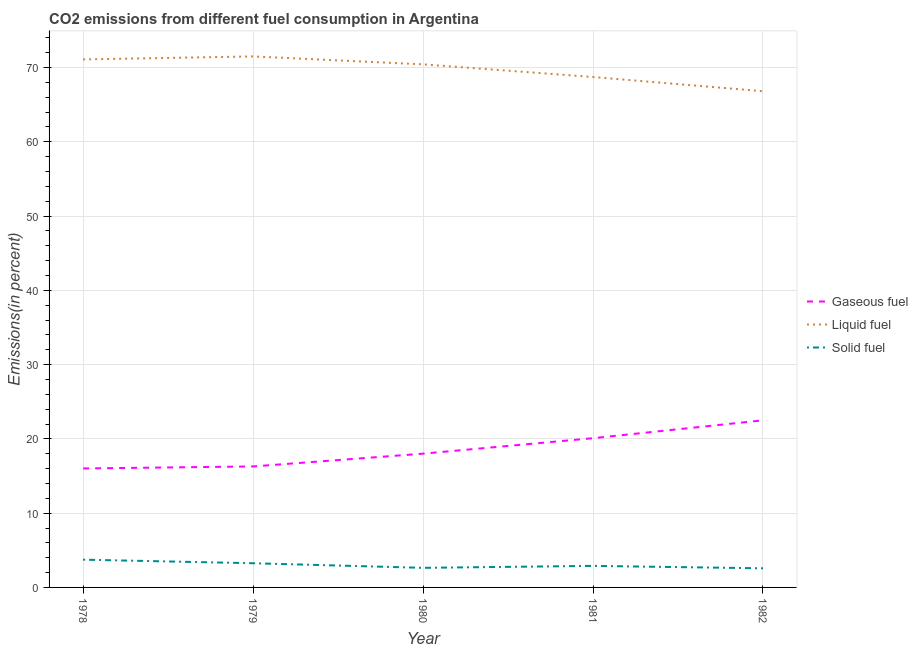How many different coloured lines are there?
Keep it short and to the point. 3. Does the line corresponding to percentage of solid fuel emission intersect with the line corresponding to percentage of gaseous fuel emission?
Ensure brevity in your answer.  No. Is the number of lines equal to the number of legend labels?
Your answer should be compact. Yes. What is the percentage of liquid fuel emission in 1980?
Give a very brief answer. 70.42. Across all years, what is the maximum percentage of liquid fuel emission?
Give a very brief answer. 71.49. Across all years, what is the minimum percentage of solid fuel emission?
Your answer should be compact. 2.57. In which year was the percentage of liquid fuel emission maximum?
Your response must be concise. 1979. What is the total percentage of liquid fuel emission in the graph?
Your answer should be compact. 348.5. What is the difference between the percentage of liquid fuel emission in 1979 and that in 1981?
Your answer should be compact. 2.77. What is the difference between the percentage of liquid fuel emission in 1981 and the percentage of solid fuel emission in 1982?
Your answer should be very brief. 66.14. What is the average percentage of gaseous fuel emission per year?
Ensure brevity in your answer.  18.58. In the year 1979, what is the difference between the percentage of solid fuel emission and percentage of gaseous fuel emission?
Make the answer very short. -13.03. What is the ratio of the percentage of gaseous fuel emission in 1979 to that in 1981?
Offer a terse response. 0.81. What is the difference between the highest and the second highest percentage of gaseous fuel emission?
Ensure brevity in your answer.  2.4. What is the difference between the highest and the lowest percentage of solid fuel emission?
Offer a very short reply. 1.16. Is the percentage of liquid fuel emission strictly greater than the percentage of gaseous fuel emission over the years?
Your answer should be very brief. Yes. How many lines are there?
Offer a terse response. 3. How many legend labels are there?
Provide a short and direct response. 3. What is the title of the graph?
Provide a succinct answer. CO2 emissions from different fuel consumption in Argentina. Does "Tertiary education" appear as one of the legend labels in the graph?
Your response must be concise. No. What is the label or title of the Y-axis?
Ensure brevity in your answer.  Emissions(in percent). What is the Emissions(in percent) in Gaseous fuel in 1978?
Your response must be concise. 16.02. What is the Emissions(in percent) in Liquid fuel in 1978?
Your response must be concise. 71.08. What is the Emissions(in percent) in Solid fuel in 1978?
Keep it short and to the point. 3.74. What is the Emissions(in percent) in Gaseous fuel in 1979?
Your response must be concise. 16.29. What is the Emissions(in percent) of Liquid fuel in 1979?
Offer a very short reply. 71.49. What is the Emissions(in percent) of Solid fuel in 1979?
Your answer should be compact. 3.26. What is the Emissions(in percent) of Gaseous fuel in 1980?
Keep it short and to the point. 18.01. What is the Emissions(in percent) of Liquid fuel in 1980?
Your answer should be compact. 70.42. What is the Emissions(in percent) of Solid fuel in 1980?
Your response must be concise. 2.64. What is the Emissions(in percent) of Gaseous fuel in 1981?
Ensure brevity in your answer.  20.09. What is the Emissions(in percent) of Liquid fuel in 1981?
Offer a terse response. 68.71. What is the Emissions(in percent) in Solid fuel in 1981?
Provide a short and direct response. 2.9. What is the Emissions(in percent) of Gaseous fuel in 1982?
Give a very brief answer. 22.5. What is the Emissions(in percent) of Liquid fuel in 1982?
Make the answer very short. 66.8. What is the Emissions(in percent) in Solid fuel in 1982?
Offer a terse response. 2.57. Across all years, what is the maximum Emissions(in percent) in Gaseous fuel?
Offer a terse response. 22.5. Across all years, what is the maximum Emissions(in percent) of Liquid fuel?
Offer a terse response. 71.49. Across all years, what is the maximum Emissions(in percent) in Solid fuel?
Your response must be concise. 3.74. Across all years, what is the minimum Emissions(in percent) in Gaseous fuel?
Your answer should be compact. 16.02. Across all years, what is the minimum Emissions(in percent) in Liquid fuel?
Provide a short and direct response. 66.8. Across all years, what is the minimum Emissions(in percent) of Solid fuel?
Provide a short and direct response. 2.57. What is the total Emissions(in percent) of Gaseous fuel in the graph?
Make the answer very short. 92.9. What is the total Emissions(in percent) of Liquid fuel in the graph?
Make the answer very short. 348.5. What is the total Emissions(in percent) in Solid fuel in the graph?
Your answer should be very brief. 15.1. What is the difference between the Emissions(in percent) in Gaseous fuel in 1978 and that in 1979?
Offer a very short reply. -0.27. What is the difference between the Emissions(in percent) of Liquid fuel in 1978 and that in 1979?
Keep it short and to the point. -0.4. What is the difference between the Emissions(in percent) of Solid fuel in 1978 and that in 1979?
Provide a succinct answer. 0.48. What is the difference between the Emissions(in percent) of Gaseous fuel in 1978 and that in 1980?
Give a very brief answer. -1.99. What is the difference between the Emissions(in percent) of Liquid fuel in 1978 and that in 1980?
Offer a very short reply. 0.66. What is the difference between the Emissions(in percent) in Solid fuel in 1978 and that in 1980?
Provide a short and direct response. 1.1. What is the difference between the Emissions(in percent) of Gaseous fuel in 1978 and that in 1981?
Your answer should be compact. -4.08. What is the difference between the Emissions(in percent) in Liquid fuel in 1978 and that in 1981?
Your response must be concise. 2.37. What is the difference between the Emissions(in percent) of Solid fuel in 1978 and that in 1981?
Your answer should be compact. 0.84. What is the difference between the Emissions(in percent) of Gaseous fuel in 1978 and that in 1982?
Provide a succinct answer. -6.48. What is the difference between the Emissions(in percent) of Liquid fuel in 1978 and that in 1982?
Ensure brevity in your answer.  4.28. What is the difference between the Emissions(in percent) in Solid fuel in 1978 and that in 1982?
Offer a terse response. 1.16. What is the difference between the Emissions(in percent) in Gaseous fuel in 1979 and that in 1980?
Provide a succinct answer. -1.72. What is the difference between the Emissions(in percent) in Liquid fuel in 1979 and that in 1980?
Your response must be concise. 1.07. What is the difference between the Emissions(in percent) in Solid fuel in 1979 and that in 1980?
Offer a very short reply. 0.62. What is the difference between the Emissions(in percent) of Gaseous fuel in 1979 and that in 1981?
Offer a very short reply. -3.8. What is the difference between the Emissions(in percent) in Liquid fuel in 1979 and that in 1981?
Offer a very short reply. 2.77. What is the difference between the Emissions(in percent) in Solid fuel in 1979 and that in 1981?
Your answer should be compact. 0.36. What is the difference between the Emissions(in percent) in Gaseous fuel in 1979 and that in 1982?
Provide a succinct answer. -6.21. What is the difference between the Emissions(in percent) in Liquid fuel in 1979 and that in 1982?
Offer a very short reply. 4.69. What is the difference between the Emissions(in percent) of Solid fuel in 1979 and that in 1982?
Your response must be concise. 0.68. What is the difference between the Emissions(in percent) of Gaseous fuel in 1980 and that in 1981?
Your answer should be very brief. -2.08. What is the difference between the Emissions(in percent) in Liquid fuel in 1980 and that in 1981?
Your response must be concise. 1.7. What is the difference between the Emissions(in percent) in Solid fuel in 1980 and that in 1981?
Your answer should be compact. -0.26. What is the difference between the Emissions(in percent) in Gaseous fuel in 1980 and that in 1982?
Keep it short and to the point. -4.49. What is the difference between the Emissions(in percent) in Liquid fuel in 1980 and that in 1982?
Make the answer very short. 3.62. What is the difference between the Emissions(in percent) in Solid fuel in 1980 and that in 1982?
Give a very brief answer. 0.06. What is the difference between the Emissions(in percent) in Gaseous fuel in 1981 and that in 1982?
Keep it short and to the point. -2.4. What is the difference between the Emissions(in percent) of Liquid fuel in 1981 and that in 1982?
Provide a short and direct response. 1.91. What is the difference between the Emissions(in percent) of Solid fuel in 1981 and that in 1982?
Your response must be concise. 0.33. What is the difference between the Emissions(in percent) of Gaseous fuel in 1978 and the Emissions(in percent) of Liquid fuel in 1979?
Provide a short and direct response. -55.47. What is the difference between the Emissions(in percent) in Gaseous fuel in 1978 and the Emissions(in percent) in Solid fuel in 1979?
Your answer should be compact. 12.76. What is the difference between the Emissions(in percent) of Liquid fuel in 1978 and the Emissions(in percent) of Solid fuel in 1979?
Your answer should be compact. 67.83. What is the difference between the Emissions(in percent) of Gaseous fuel in 1978 and the Emissions(in percent) of Liquid fuel in 1980?
Your answer should be very brief. -54.4. What is the difference between the Emissions(in percent) in Gaseous fuel in 1978 and the Emissions(in percent) in Solid fuel in 1980?
Your answer should be very brief. 13.38. What is the difference between the Emissions(in percent) of Liquid fuel in 1978 and the Emissions(in percent) of Solid fuel in 1980?
Provide a short and direct response. 68.45. What is the difference between the Emissions(in percent) of Gaseous fuel in 1978 and the Emissions(in percent) of Liquid fuel in 1981?
Offer a terse response. -52.7. What is the difference between the Emissions(in percent) of Gaseous fuel in 1978 and the Emissions(in percent) of Solid fuel in 1981?
Offer a very short reply. 13.12. What is the difference between the Emissions(in percent) in Liquid fuel in 1978 and the Emissions(in percent) in Solid fuel in 1981?
Your answer should be very brief. 68.18. What is the difference between the Emissions(in percent) in Gaseous fuel in 1978 and the Emissions(in percent) in Liquid fuel in 1982?
Give a very brief answer. -50.78. What is the difference between the Emissions(in percent) of Gaseous fuel in 1978 and the Emissions(in percent) of Solid fuel in 1982?
Make the answer very short. 13.44. What is the difference between the Emissions(in percent) in Liquid fuel in 1978 and the Emissions(in percent) in Solid fuel in 1982?
Offer a very short reply. 68.51. What is the difference between the Emissions(in percent) in Gaseous fuel in 1979 and the Emissions(in percent) in Liquid fuel in 1980?
Your answer should be very brief. -54.13. What is the difference between the Emissions(in percent) of Gaseous fuel in 1979 and the Emissions(in percent) of Solid fuel in 1980?
Provide a short and direct response. 13.65. What is the difference between the Emissions(in percent) of Liquid fuel in 1979 and the Emissions(in percent) of Solid fuel in 1980?
Your response must be concise. 68.85. What is the difference between the Emissions(in percent) of Gaseous fuel in 1979 and the Emissions(in percent) of Liquid fuel in 1981?
Provide a succinct answer. -52.43. What is the difference between the Emissions(in percent) in Gaseous fuel in 1979 and the Emissions(in percent) in Solid fuel in 1981?
Your answer should be compact. 13.39. What is the difference between the Emissions(in percent) of Liquid fuel in 1979 and the Emissions(in percent) of Solid fuel in 1981?
Provide a succinct answer. 68.59. What is the difference between the Emissions(in percent) of Gaseous fuel in 1979 and the Emissions(in percent) of Liquid fuel in 1982?
Ensure brevity in your answer.  -50.51. What is the difference between the Emissions(in percent) in Gaseous fuel in 1979 and the Emissions(in percent) in Solid fuel in 1982?
Offer a terse response. 13.71. What is the difference between the Emissions(in percent) in Liquid fuel in 1979 and the Emissions(in percent) in Solid fuel in 1982?
Provide a short and direct response. 68.91. What is the difference between the Emissions(in percent) of Gaseous fuel in 1980 and the Emissions(in percent) of Liquid fuel in 1981?
Provide a short and direct response. -50.71. What is the difference between the Emissions(in percent) of Gaseous fuel in 1980 and the Emissions(in percent) of Solid fuel in 1981?
Offer a terse response. 15.11. What is the difference between the Emissions(in percent) of Liquid fuel in 1980 and the Emissions(in percent) of Solid fuel in 1981?
Ensure brevity in your answer.  67.52. What is the difference between the Emissions(in percent) of Gaseous fuel in 1980 and the Emissions(in percent) of Liquid fuel in 1982?
Offer a very short reply. -48.79. What is the difference between the Emissions(in percent) of Gaseous fuel in 1980 and the Emissions(in percent) of Solid fuel in 1982?
Your answer should be very brief. 15.43. What is the difference between the Emissions(in percent) of Liquid fuel in 1980 and the Emissions(in percent) of Solid fuel in 1982?
Offer a very short reply. 67.84. What is the difference between the Emissions(in percent) of Gaseous fuel in 1981 and the Emissions(in percent) of Liquid fuel in 1982?
Your answer should be compact. -46.71. What is the difference between the Emissions(in percent) in Gaseous fuel in 1981 and the Emissions(in percent) in Solid fuel in 1982?
Offer a very short reply. 17.52. What is the difference between the Emissions(in percent) of Liquid fuel in 1981 and the Emissions(in percent) of Solid fuel in 1982?
Make the answer very short. 66.14. What is the average Emissions(in percent) in Gaseous fuel per year?
Offer a very short reply. 18.58. What is the average Emissions(in percent) in Liquid fuel per year?
Offer a very short reply. 69.7. What is the average Emissions(in percent) of Solid fuel per year?
Ensure brevity in your answer.  3.02. In the year 1978, what is the difference between the Emissions(in percent) of Gaseous fuel and Emissions(in percent) of Liquid fuel?
Ensure brevity in your answer.  -55.07. In the year 1978, what is the difference between the Emissions(in percent) in Gaseous fuel and Emissions(in percent) in Solid fuel?
Make the answer very short. 12.28. In the year 1978, what is the difference between the Emissions(in percent) of Liquid fuel and Emissions(in percent) of Solid fuel?
Your answer should be very brief. 67.35. In the year 1979, what is the difference between the Emissions(in percent) of Gaseous fuel and Emissions(in percent) of Liquid fuel?
Provide a succinct answer. -55.2. In the year 1979, what is the difference between the Emissions(in percent) of Gaseous fuel and Emissions(in percent) of Solid fuel?
Give a very brief answer. 13.03. In the year 1979, what is the difference between the Emissions(in percent) in Liquid fuel and Emissions(in percent) in Solid fuel?
Provide a succinct answer. 68.23. In the year 1980, what is the difference between the Emissions(in percent) in Gaseous fuel and Emissions(in percent) in Liquid fuel?
Ensure brevity in your answer.  -52.41. In the year 1980, what is the difference between the Emissions(in percent) in Gaseous fuel and Emissions(in percent) in Solid fuel?
Provide a succinct answer. 15.37. In the year 1980, what is the difference between the Emissions(in percent) of Liquid fuel and Emissions(in percent) of Solid fuel?
Make the answer very short. 67.78. In the year 1981, what is the difference between the Emissions(in percent) of Gaseous fuel and Emissions(in percent) of Liquid fuel?
Offer a terse response. -48.62. In the year 1981, what is the difference between the Emissions(in percent) in Gaseous fuel and Emissions(in percent) in Solid fuel?
Make the answer very short. 17.19. In the year 1981, what is the difference between the Emissions(in percent) in Liquid fuel and Emissions(in percent) in Solid fuel?
Keep it short and to the point. 65.81. In the year 1982, what is the difference between the Emissions(in percent) in Gaseous fuel and Emissions(in percent) in Liquid fuel?
Your response must be concise. -44.3. In the year 1982, what is the difference between the Emissions(in percent) of Gaseous fuel and Emissions(in percent) of Solid fuel?
Offer a terse response. 19.92. In the year 1982, what is the difference between the Emissions(in percent) of Liquid fuel and Emissions(in percent) of Solid fuel?
Offer a very short reply. 64.22. What is the ratio of the Emissions(in percent) in Gaseous fuel in 1978 to that in 1979?
Keep it short and to the point. 0.98. What is the ratio of the Emissions(in percent) in Solid fuel in 1978 to that in 1979?
Keep it short and to the point. 1.15. What is the ratio of the Emissions(in percent) of Gaseous fuel in 1978 to that in 1980?
Your answer should be compact. 0.89. What is the ratio of the Emissions(in percent) in Liquid fuel in 1978 to that in 1980?
Your answer should be compact. 1.01. What is the ratio of the Emissions(in percent) in Solid fuel in 1978 to that in 1980?
Offer a very short reply. 1.42. What is the ratio of the Emissions(in percent) of Gaseous fuel in 1978 to that in 1981?
Give a very brief answer. 0.8. What is the ratio of the Emissions(in percent) in Liquid fuel in 1978 to that in 1981?
Your response must be concise. 1.03. What is the ratio of the Emissions(in percent) in Solid fuel in 1978 to that in 1981?
Keep it short and to the point. 1.29. What is the ratio of the Emissions(in percent) of Gaseous fuel in 1978 to that in 1982?
Ensure brevity in your answer.  0.71. What is the ratio of the Emissions(in percent) of Liquid fuel in 1978 to that in 1982?
Make the answer very short. 1.06. What is the ratio of the Emissions(in percent) in Solid fuel in 1978 to that in 1982?
Keep it short and to the point. 1.45. What is the ratio of the Emissions(in percent) in Gaseous fuel in 1979 to that in 1980?
Ensure brevity in your answer.  0.9. What is the ratio of the Emissions(in percent) of Liquid fuel in 1979 to that in 1980?
Your answer should be compact. 1.02. What is the ratio of the Emissions(in percent) of Solid fuel in 1979 to that in 1980?
Give a very brief answer. 1.23. What is the ratio of the Emissions(in percent) of Gaseous fuel in 1979 to that in 1981?
Provide a succinct answer. 0.81. What is the ratio of the Emissions(in percent) in Liquid fuel in 1979 to that in 1981?
Offer a terse response. 1.04. What is the ratio of the Emissions(in percent) in Solid fuel in 1979 to that in 1981?
Offer a very short reply. 1.12. What is the ratio of the Emissions(in percent) of Gaseous fuel in 1979 to that in 1982?
Your answer should be compact. 0.72. What is the ratio of the Emissions(in percent) of Liquid fuel in 1979 to that in 1982?
Offer a terse response. 1.07. What is the ratio of the Emissions(in percent) in Solid fuel in 1979 to that in 1982?
Provide a short and direct response. 1.26. What is the ratio of the Emissions(in percent) of Gaseous fuel in 1980 to that in 1981?
Keep it short and to the point. 0.9. What is the ratio of the Emissions(in percent) of Liquid fuel in 1980 to that in 1981?
Provide a short and direct response. 1.02. What is the ratio of the Emissions(in percent) in Solid fuel in 1980 to that in 1981?
Give a very brief answer. 0.91. What is the ratio of the Emissions(in percent) of Gaseous fuel in 1980 to that in 1982?
Your answer should be compact. 0.8. What is the ratio of the Emissions(in percent) in Liquid fuel in 1980 to that in 1982?
Your response must be concise. 1.05. What is the ratio of the Emissions(in percent) of Solid fuel in 1980 to that in 1982?
Offer a terse response. 1.02. What is the ratio of the Emissions(in percent) of Gaseous fuel in 1981 to that in 1982?
Provide a short and direct response. 0.89. What is the ratio of the Emissions(in percent) of Liquid fuel in 1981 to that in 1982?
Your answer should be very brief. 1.03. What is the ratio of the Emissions(in percent) in Solid fuel in 1981 to that in 1982?
Make the answer very short. 1.13. What is the difference between the highest and the second highest Emissions(in percent) of Gaseous fuel?
Provide a short and direct response. 2.4. What is the difference between the highest and the second highest Emissions(in percent) of Liquid fuel?
Give a very brief answer. 0.4. What is the difference between the highest and the second highest Emissions(in percent) of Solid fuel?
Your answer should be compact. 0.48. What is the difference between the highest and the lowest Emissions(in percent) in Gaseous fuel?
Give a very brief answer. 6.48. What is the difference between the highest and the lowest Emissions(in percent) of Liquid fuel?
Your answer should be compact. 4.69. What is the difference between the highest and the lowest Emissions(in percent) in Solid fuel?
Give a very brief answer. 1.16. 